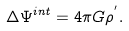<formula> <loc_0><loc_0><loc_500><loc_500>\Delta \Psi ^ { i n t } = 4 \pi G \rho ^ { ^ { \prime } } .</formula> 